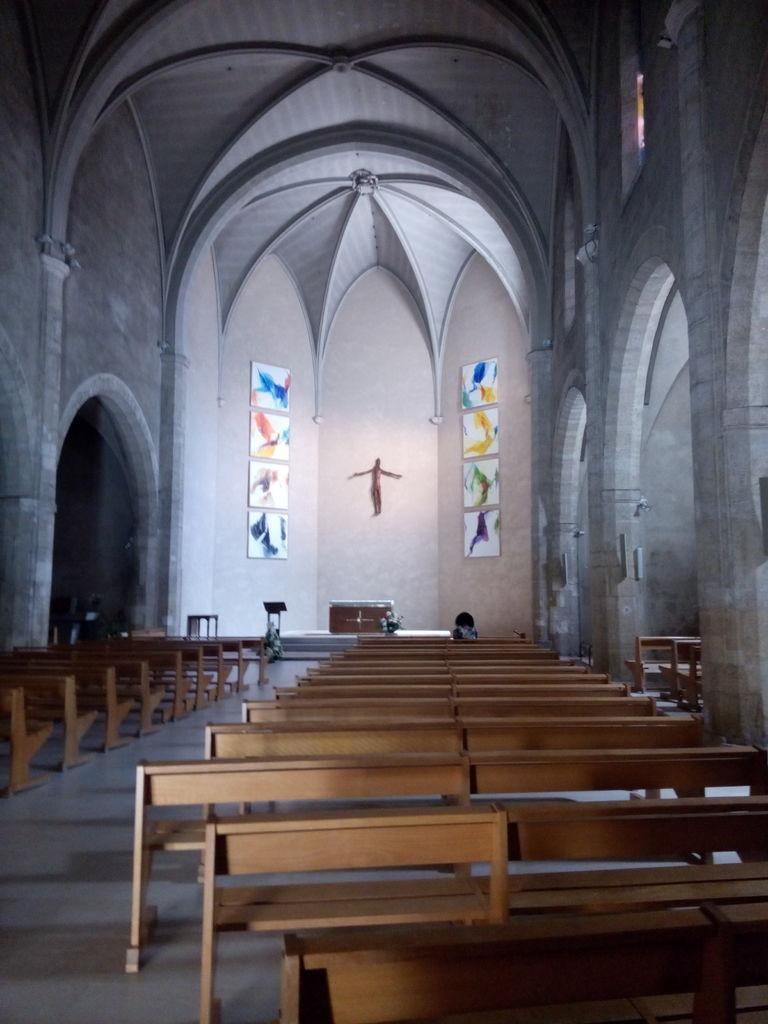Can you describe this image briefly? In this image we can see inside of a church. There are many benches in the image. There are few objects on the wall. 